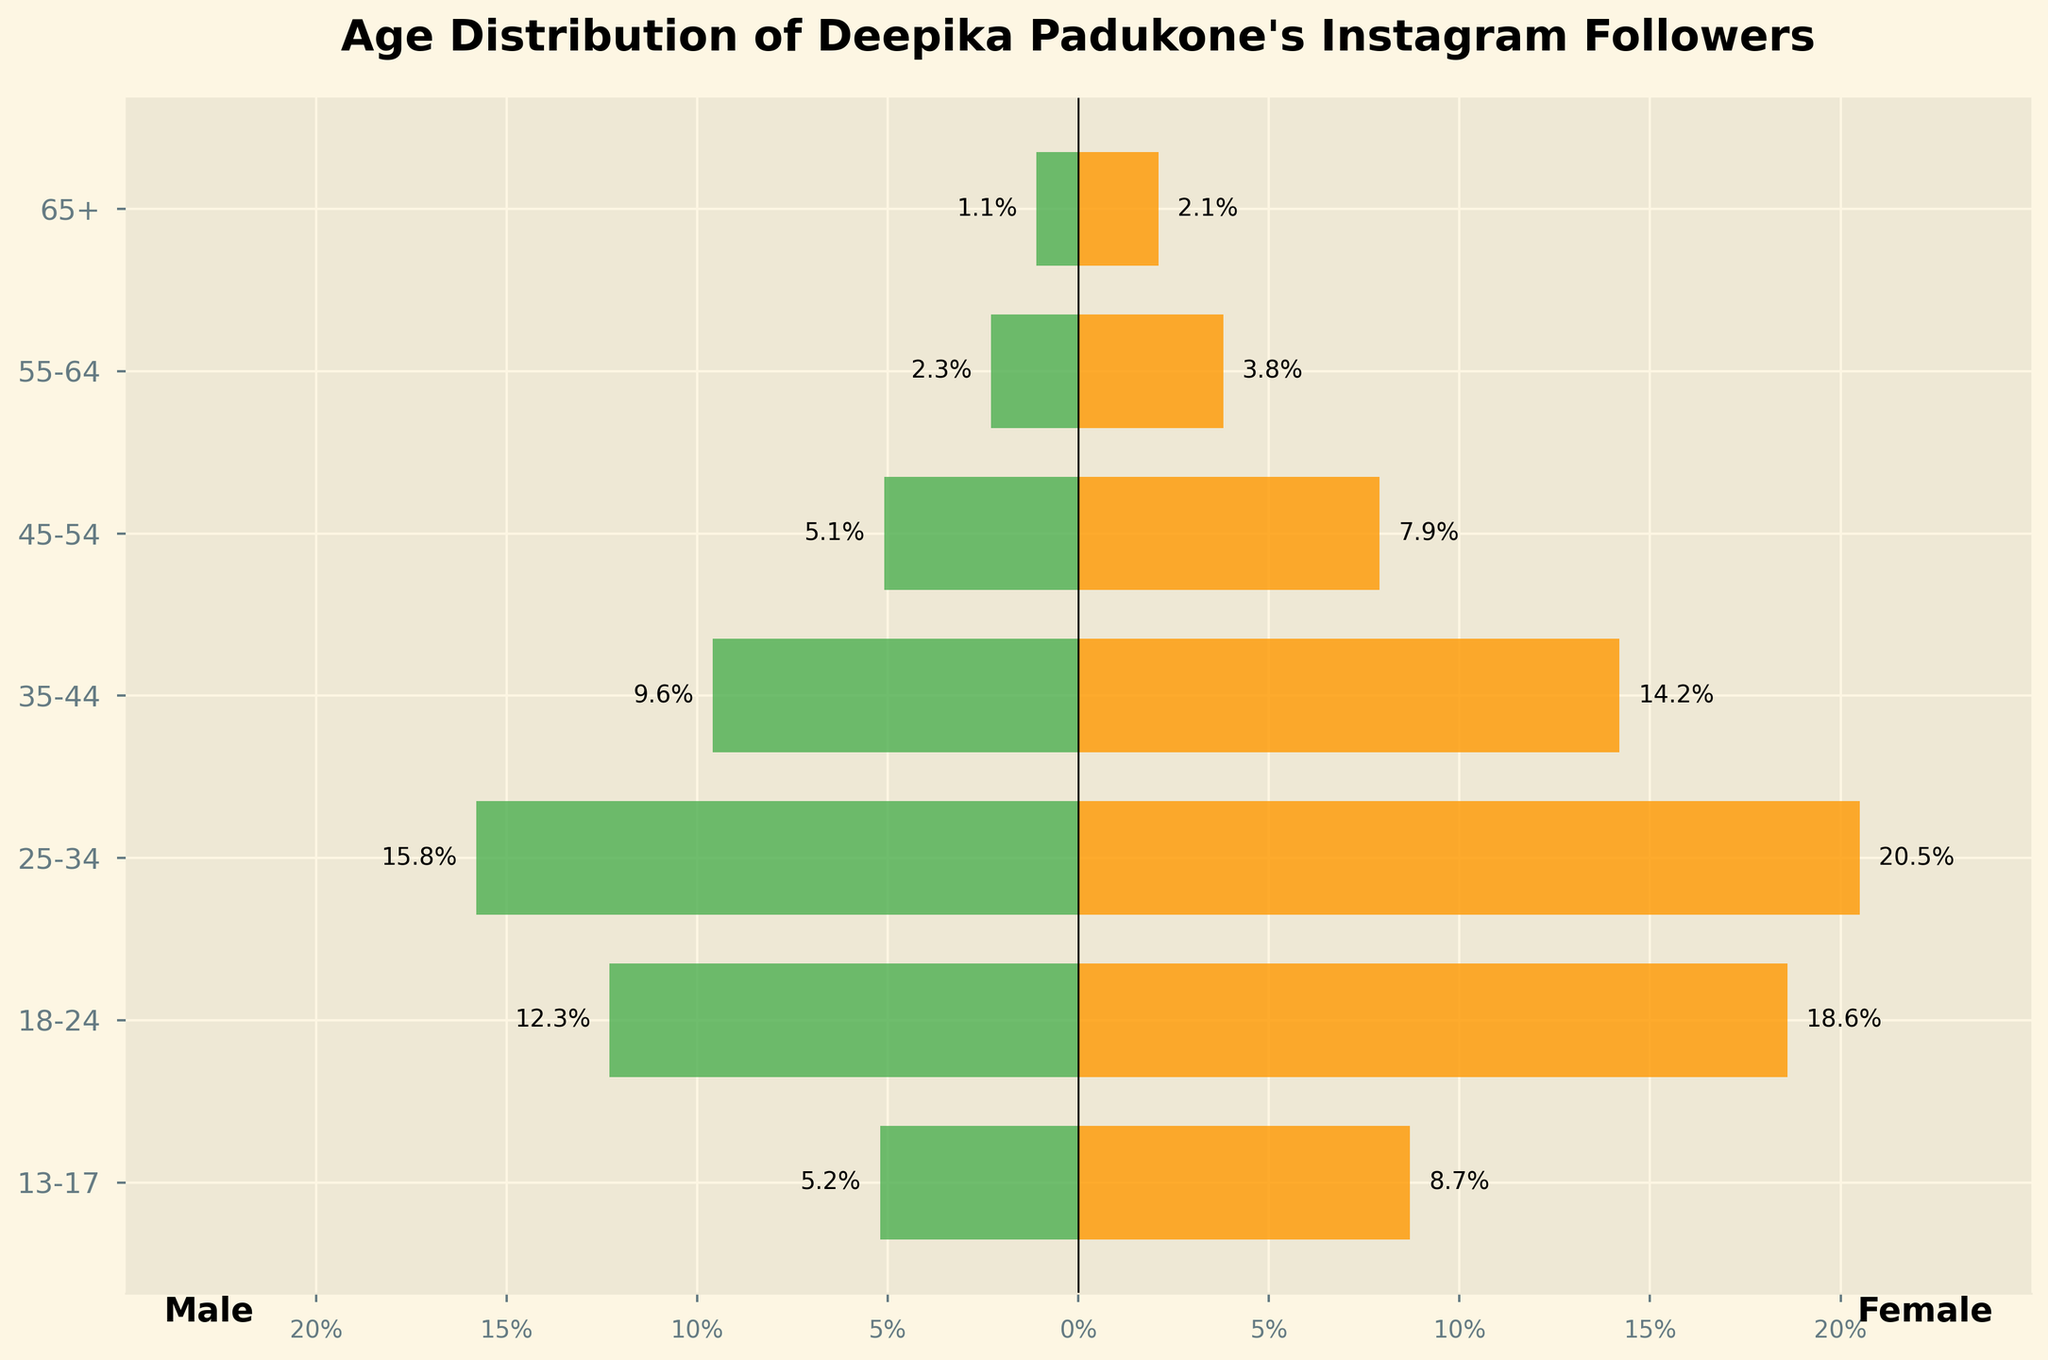What is the age range of the largest group of female followers? The largest group of female followers can be identified by looking for the age range with the highest bar on the right side of the pyramid (representing females). The '25-34' age range has the highest percentage (20.5%).
Answer: 25-34 What is the combined percentage of female followers aged 18-24 and 25-34? Combine the percentages for the 18-24 and 25-34 age ranges for females by adding them up: 18.6% + 20.5% = 39.1%.
Answer: 39.1% How does the percentage of male followers 25-34 compare to that of female followers in the same age range? Look at the 25-34 age range bars. The percentage for males is 15.8%, and for females, it's 20.5%. Compare them to see that fewer males (15.8%) follow in this age range compared to females (20.5%).
Answer: Fewer males What is the difference in percentage between male and female followers in the 35-44 age range? Subtract the percentage of male followers from female followers in the 35-44 age range: 14.2% - 9.6% = 4.6%.
Answer: 4.6% What is the total percentage of followers aged 55-64? Add the percentages of both male (2.3%) and female (3.8%) followers in the 55-64 age range: 2.3% + 3.8% = 6.1%.
Answer: 6.1% Which gender has higher representation in the 13-17 age range? Look at the bars for the 13-17 age range. The female bar (8.7%) is longer than the male bar (5.2%), indicating that females have higher representation.
Answer: Female Which age range has the smallest percentage of male followers? The age range with the shortest bar on the left side of the pyramid (representing males) is 65+, with a percentage of 1.1%.
Answer: 65+ What percentage of followers are in the 45-54 age range for both genders combined? Add the percentages of male (5.1%) and female (7.9%) followers in the 45-54 age range: 5.1% + 7.9% = 13%.
Answer: 13% What can you infer about the gender distribution for Instagram followers aged 35-44? Observing the bars for the 35-44 age range, females (14.2%) are more represented than males (9.6%). This suggests that within this age range, Deepika Padukone has a higher percentage of female followers than male followers.
Answer: More females 